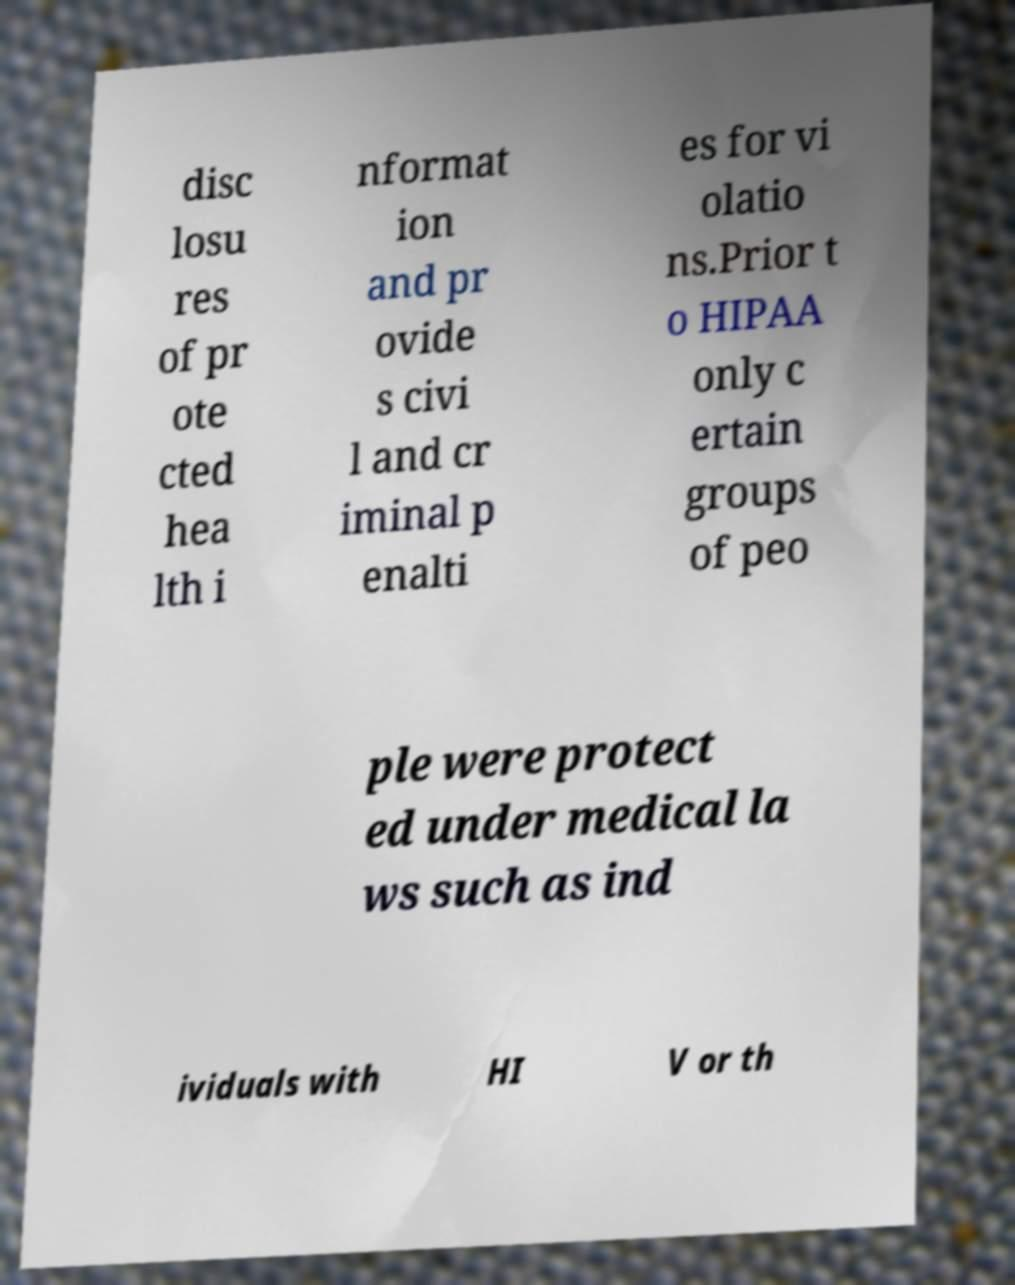Please identify and transcribe the text found in this image. disc losu res of pr ote cted hea lth i nformat ion and pr ovide s civi l and cr iminal p enalti es for vi olatio ns.Prior t o HIPAA only c ertain groups of peo ple were protect ed under medical la ws such as ind ividuals with HI V or th 